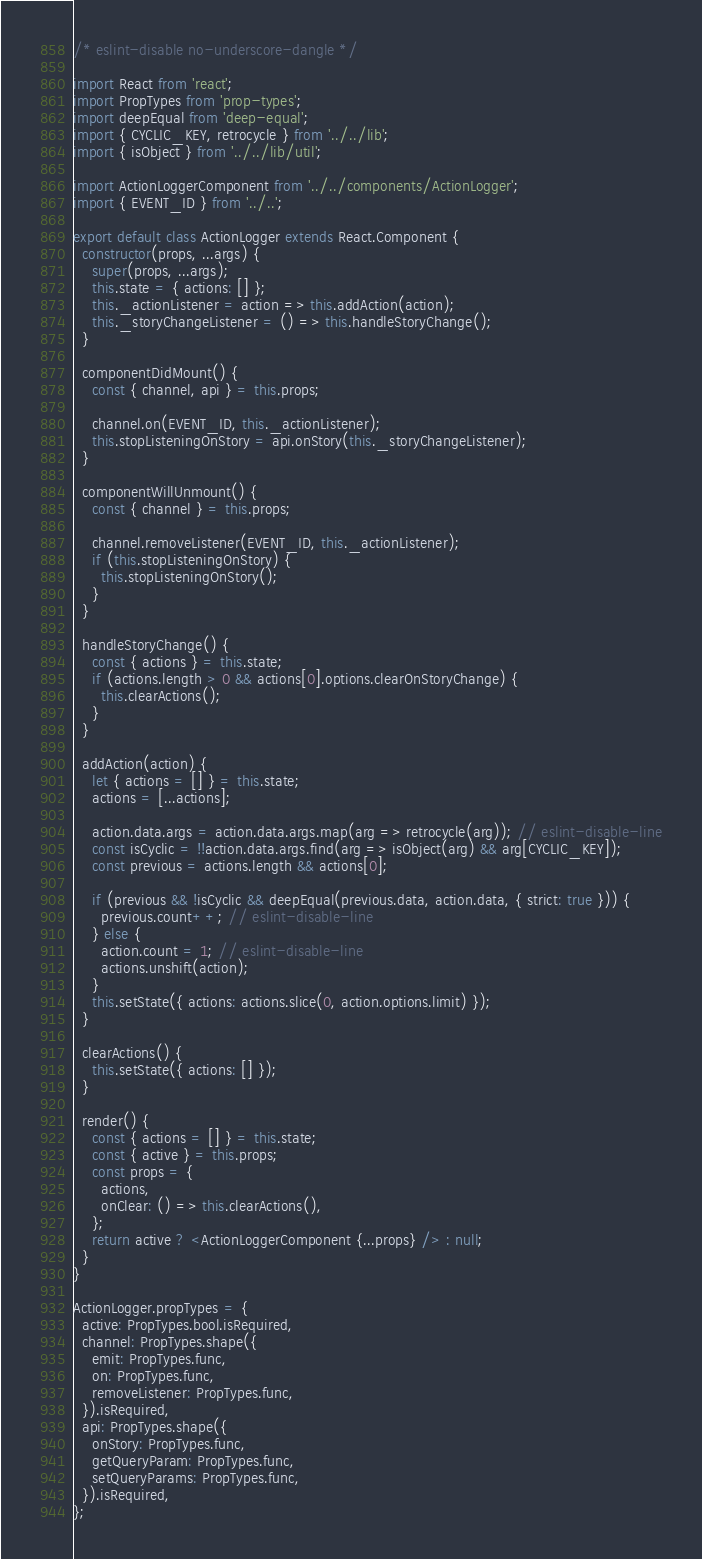<code> <loc_0><loc_0><loc_500><loc_500><_JavaScript_>/* eslint-disable no-underscore-dangle */

import React from 'react';
import PropTypes from 'prop-types';
import deepEqual from 'deep-equal';
import { CYCLIC_KEY, retrocycle } from '../../lib';
import { isObject } from '../../lib/util';

import ActionLoggerComponent from '../../components/ActionLogger';
import { EVENT_ID } from '../..';

export default class ActionLogger extends React.Component {
  constructor(props, ...args) {
    super(props, ...args);
    this.state = { actions: [] };
    this._actionListener = action => this.addAction(action);
    this._storyChangeListener = () => this.handleStoryChange();
  }

  componentDidMount() {
    const { channel, api } = this.props;

    channel.on(EVENT_ID, this._actionListener);
    this.stopListeningOnStory = api.onStory(this._storyChangeListener);
  }

  componentWillUnmount() {
    const { channel } = this.props;

    channel.removeListener(EVENT_ID, this._actionListener);
    if (this.stopListeningOnStory) {
      this.stopListeningOnStory();
    }
  }

  handleStoryChange() {
    const { actions } = this.state;
    if (actions.length > 0 && actions[0].options.clearOnStoryChange) {
      this.clearActions();
    }
  }

  addAction(action) {
    let { actions = [] } = this.state;
    actions = [...actions];

    action.data.args = action.data.args.map(arg => retrocycle(arg)); // eslint-disable-line
    const isCyclic = !!action.data.args.find(arg => isObject(arg) && arg[CYCLIC_KEY]);
    const previous = actions.length && actions[0];

    if (previous && !isCyclic && deepEqual(previous.data, action.data, { strict: true })) {
      previous.count++; // eslint-disable-line
    } else {
      action.count = 1; // eslint-disable-line
      actions.unshift(action);
    }
    this.setState({ actions: actions.slice(0, action.options.limit) });
  }

  clearActions() {
    this.setState({ actions: [] });
  }

  render() {
    const { actions = [] } = this.state;
    const { active } = this.props;
    const props = {
      actions,
      onClear: () => this.clearActions(),
    };
    return active ? <ActionLoggerComponent {...props} /> : null;
  }
}

ActionLogger.propTypes = {
  active: PropTypes.bool.isRequired,
  channel: PropTypes.shape({
    emit: PropTypes.func,
    on: PropTypes.func,
    removeListener: PropTypes.func,
  }).isRequired,
  api: PropTypes.shape({
    onStory: PropTypes.func,
    getQueryParam: PropTypes.func,
    setQueryParams: PropTypes.func,
  }).isRequired,
};
</code> 